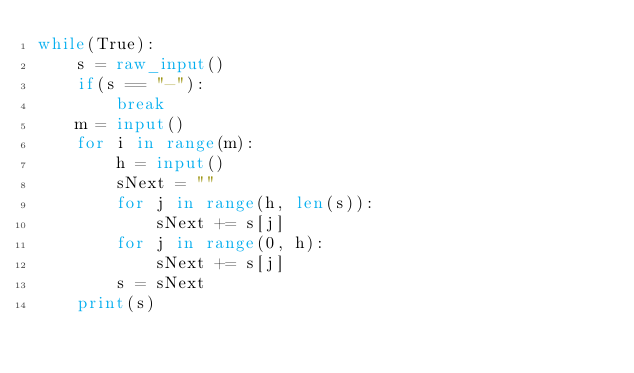<code> <loc_0><loc_0><loc_500><loc_500><_Python_>while(True):
    s = raw_input()
    if(s == "-"):
        break
    m = input()
    for i in range(m):
        h = input()
        sNext = ""
        for j in range(h, len(s)):
            sNext += s[j]
        for j in range(0, h):
            sNext += s[j]
        s = sNext
    print(s)</code> 